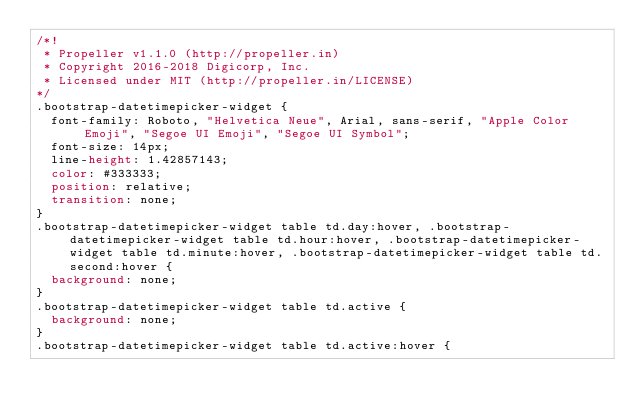<code> <loc_0><loc_0><loc_500><loc_500><_CSS_>/*!
 * Propeller v1.1.0 (http://propeller.in)
 * Copyright 2016-2018 Digicorp, Inc.
 * Licensed under MIT (http://propeller.in/LICENSE)
*/
.bootstrap-datetimepicker-widget {
  font-family: Roboto, "Helvetica Neue", Arial, sans-serif, "Apple Color Emoji", "Segoe UI Emoji", "Segoe UI Symbol";
  font-size: 14px;
  line-height: 1.42857143;
  color: #333333;
  position: relative;
  transition: none;
}
.bootstrap-datetimepicker-widget table td.day:hover, .bootstrap-datetimepicker-widget table td.hour:hover, .bootstrap-datetimepicker-widget table td.minute:hover, .bootstrap-datetimepicker-widget table td.second:hover {
  background: none;
}
.bootstrap-datetimepicker-widget table td.active {
  background: none;
}
.bootstrap-datetimepicker-widget table td.active:hover {</code> 